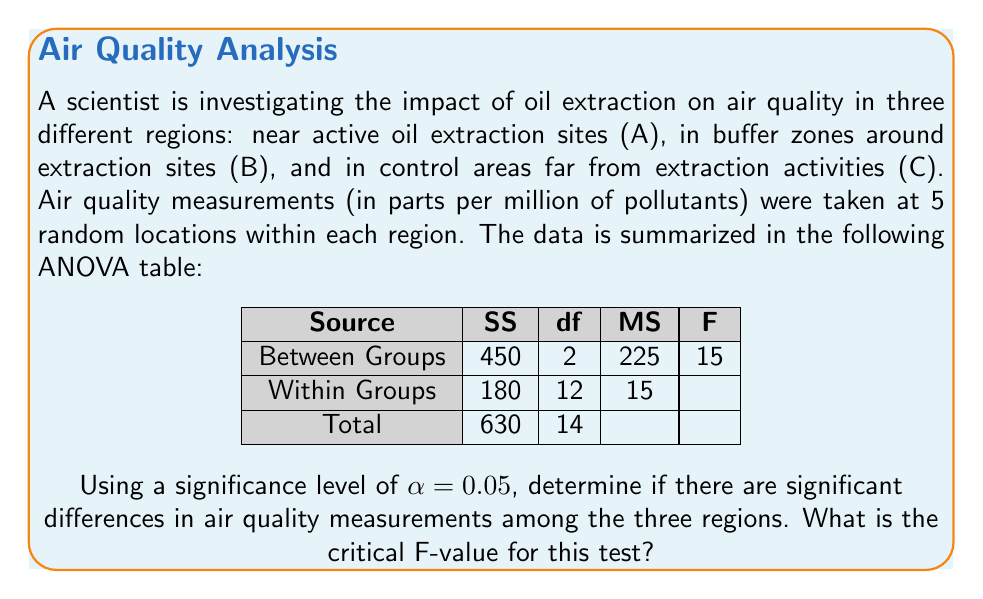Can you answer this question? To determine if there are significant differences in air quality measurements among the three regions, we need to compare the calculated F-value from the ANOVA table with the critical F-value.

Step 1: Identify the degrees of freedom
- Degrees of freedom for numerator (between groups) = 2
- Degrees of freedom for denominator (within groups) = 12

Step 2: Determine the critical F-value
Using an F-distribution table or calculator with $\alpha = 0.05$, df1 = 2, and df2 = 12, we find:
$$F_{critical} = F_{0.05, 2, 12} = 3.89$$

Step 3: Compare the calculated F-value with the critical F-value
From the ANOVA table, we see that the calculated F-value is 15.

Since $15 > 3.89$, we reject the null hypothesis.

Step 4: Interpret the results
The calculated F-value (15) is greater than the critical F-value (3.89), indicating that there are significant differences in air quality measurements among the three regions (near active oil extraction sites, buffer zones, and control areas) at the 0.05 significance level.
Answer: $F_{critical} = 3.89$ 